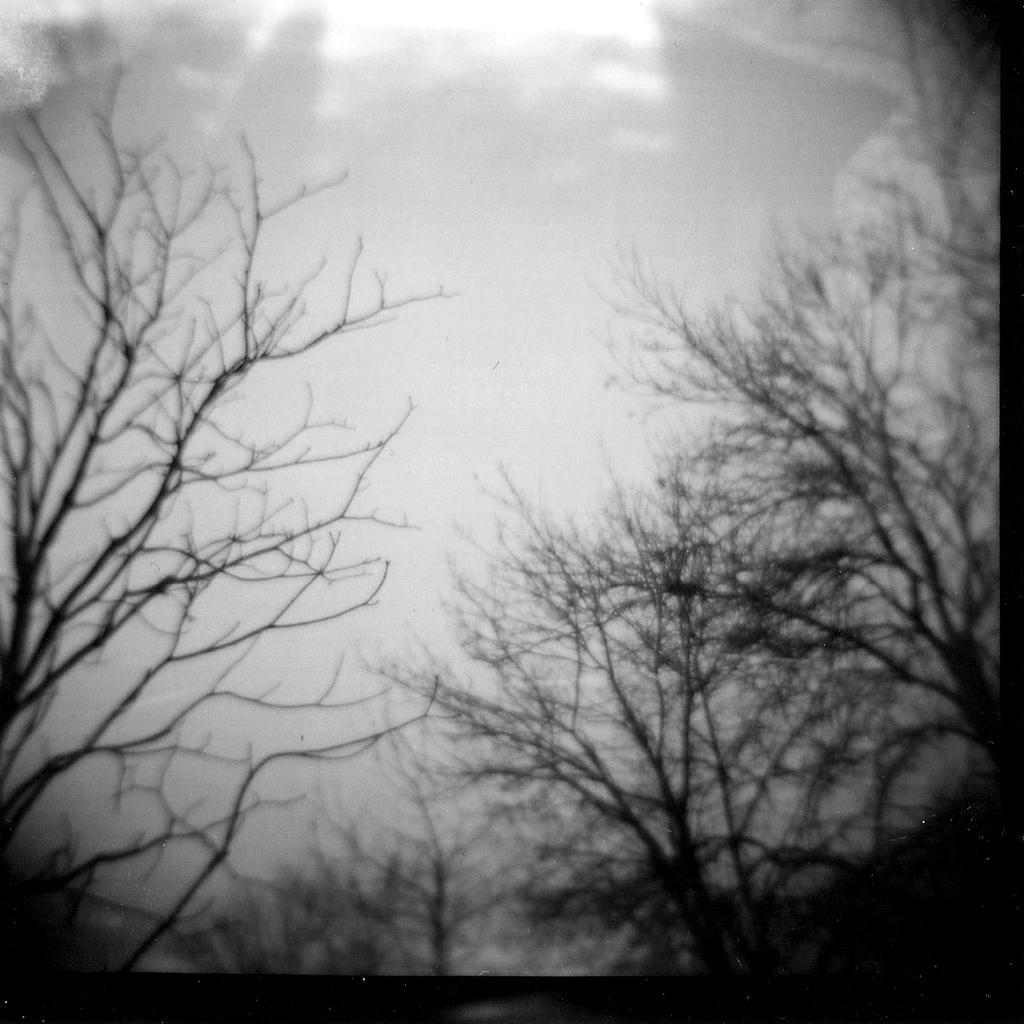What type of vegetation can be seen on the left side of the image? There are trees on the left side of the image. What type of vegetation can be seen on the right side of the image? There are trees on the right side of the image. What is visible in the background of the image? The sky is visible in the image. What can be observed in the sky? Clouds are present in the sky. Who is the creator of the clouds in the image? The image does not provide information about the creator of the clouds; clouds are formed naturally in the atmosphere. 